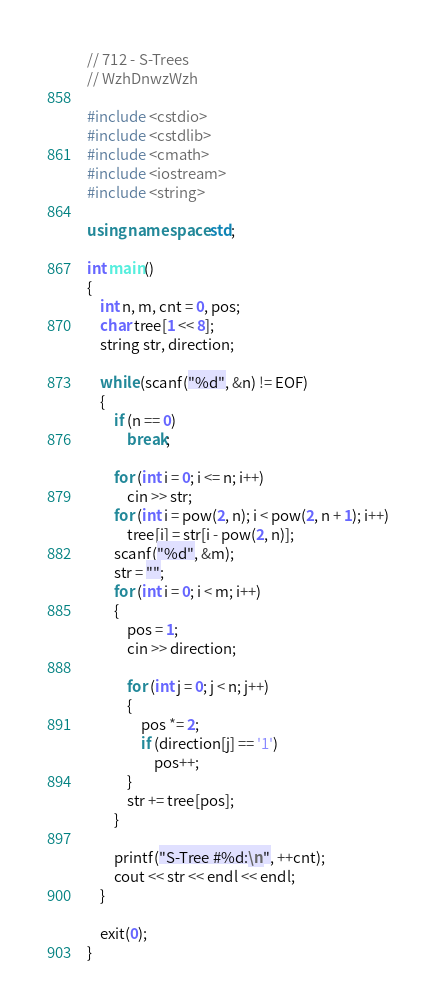Convert code to text. <code><loc_0><loc_0><loc_500><loc_500><_C++_>// 712 - S-Trees
// WzhDnwzWzh

#include <cstdio>
#include <cstdlib>
#include <cmath>
#include <iostream>
#include <string>

using namespace std;

int main()
{
    int n, m, cnt = 0, pos;
    char tree[1 << 8];
    string str, direction;

    while (scanf("%d", &n) != EOF)
    {
        if (n == 0)
            break;

        for (int i = 0; i <= n; i++)
            cin >> str;
        for (int i = pow(2, n); i < pow(2, n + 1); i++)
            tree[i] = str[i - pow(2, n)];
        scanf("%d", &m);
        str = "";
        for (int i = 0; i < m; i++)
        {
            pos = 1;
            cin >> direction;

            for (int j = 0; j < n; j++)
            {
                pos *= 2;
                if (direction[j] == '1')
                    pos++;
            }
            str += tree[pos];
        }

        printf("S-Tree #%d:\n", ++cnt);
        cout << str << endl << endl;
    }

    exit(0);
}</code> 